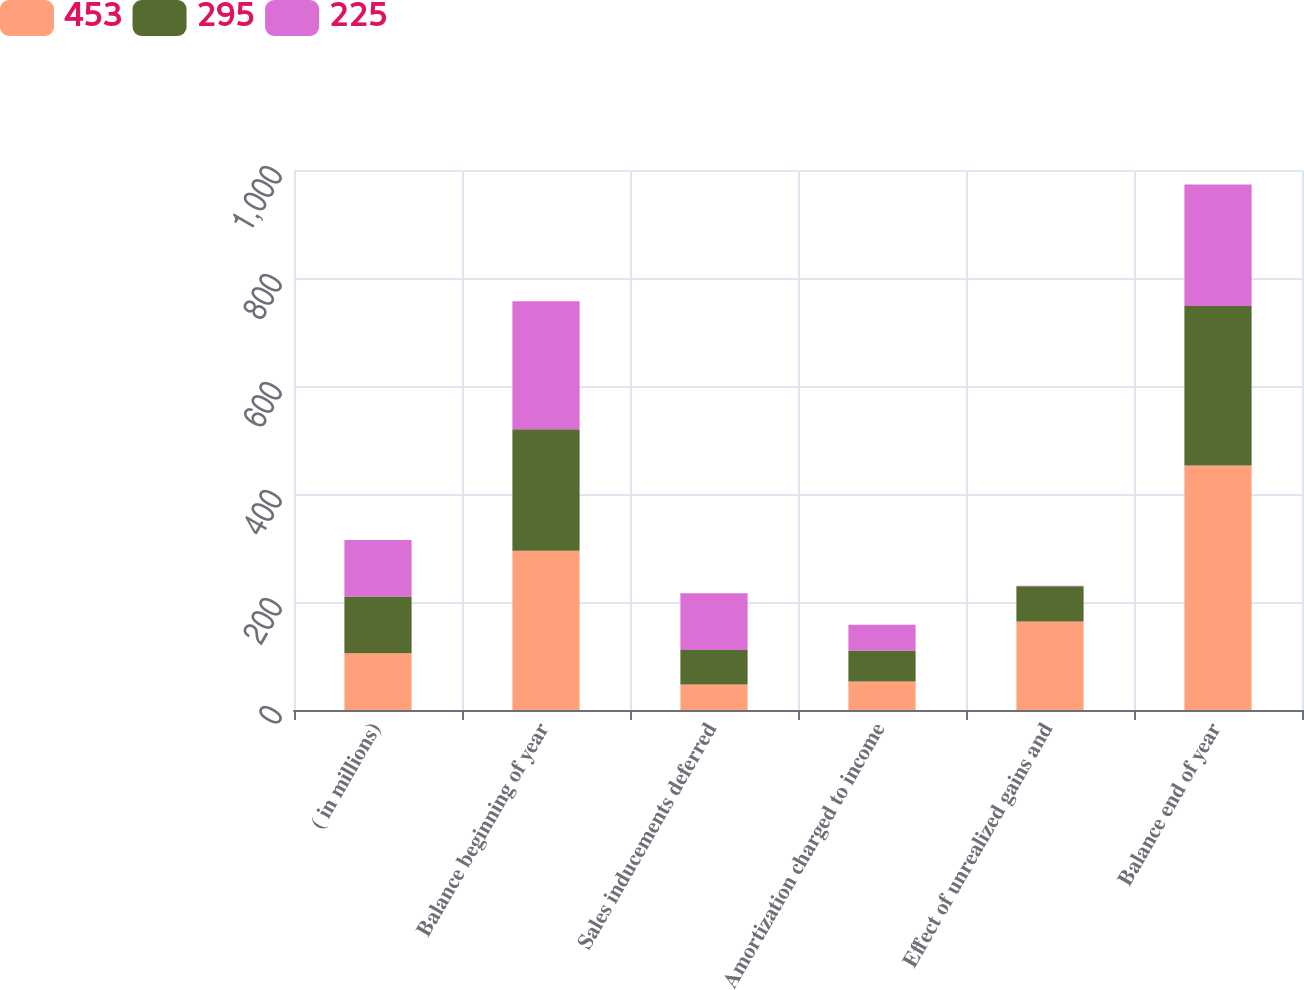<chart> <loc_0><loc_0><loc_500><loc_500><stacked_bar_chart><ecel><fcel>( in millions)<fcel>Balance beginning of year<fcel>Sales inducements deferred<fcel>Amortization charged to income<fcel>Effect of unrealized gains and<fcel>Balance end of year<nl><fcel>453<fcel>105<fcel>295<fcel>47<fcel>53<fcel>164<fcel>453<nl><fcel>295<fcel>105<fcel>225<fcel>64<fcel>57<fcel>65<fcel>295<nl><fcel>225<fcel>105<fcel>237<fcel>105<fcel>48<fcel>1<fcel>225<nl></chart> 